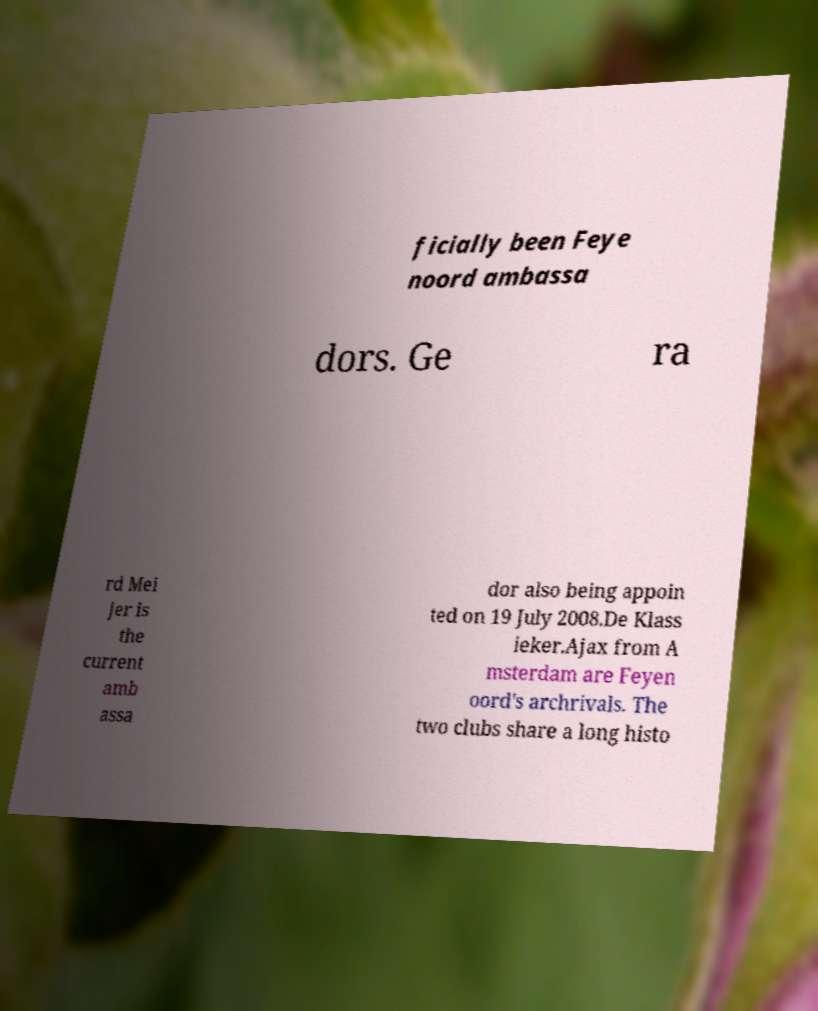Could you assist in decoding the text presented in this image and type it out clearly? ficially been Feye noord ambassa dors. Ge ra rd Mei jer is the current amb assa dor also being appoin ted on 19 July 2008.De Klass ieker.Ajax from A msterdam are Feyen oord's archrivals. The two clubs share a long histo 